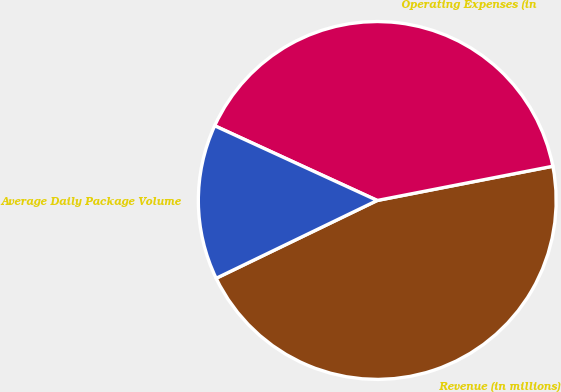Convert chart. <chart><loc_0><loc_0><loc_500><loc_500><pie_chart><fcel>Revenue (in millions)<fcel>Operating Expenses (in<fcel>Average Daily Package Volume<nl><fcel>45.9%<fcel>40.08%<fcel>14.02%<nl></chart> 